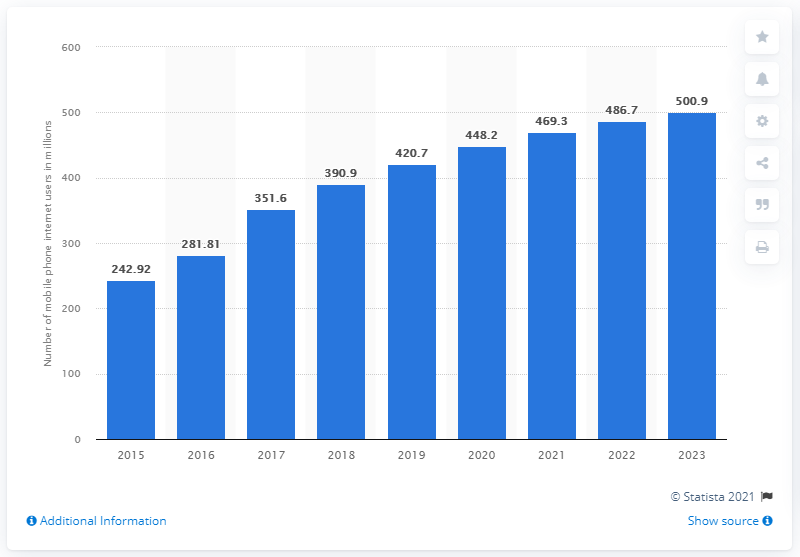Outline some significant characteristics in this image. In 2018, it is estimated that 390.9 million Indians accessed the internet through their mobile phones. By 2023, it is estimated that approximately 500.9 people will be using the internet. In 2018, the number of internet users in India was 486.7 million. 